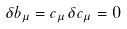Convert formula to latex. <formula><loc_0><loc_0><loc_500><loc_500>\delta b _ { \mu } = c _ { \mu } \, \delta c _ { \mu } = 0</formula> 